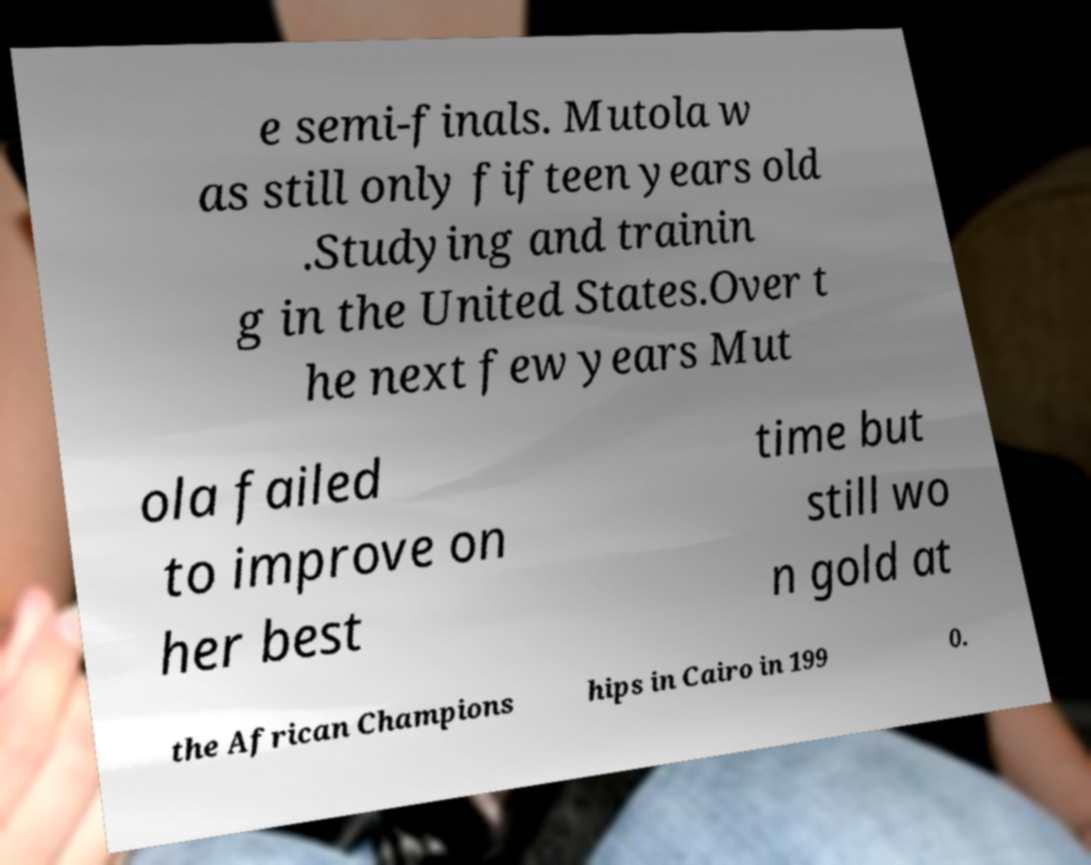Can you accurately transcribe the text from the provided image for me? e semi-finals. Mutola w as still only fifteen years old .Studying and trainin g in the United States.Over t he next few years Mut ola failed to improve on her best time but still wo n gold at the African Champions hips in Cairo in 199 0. 